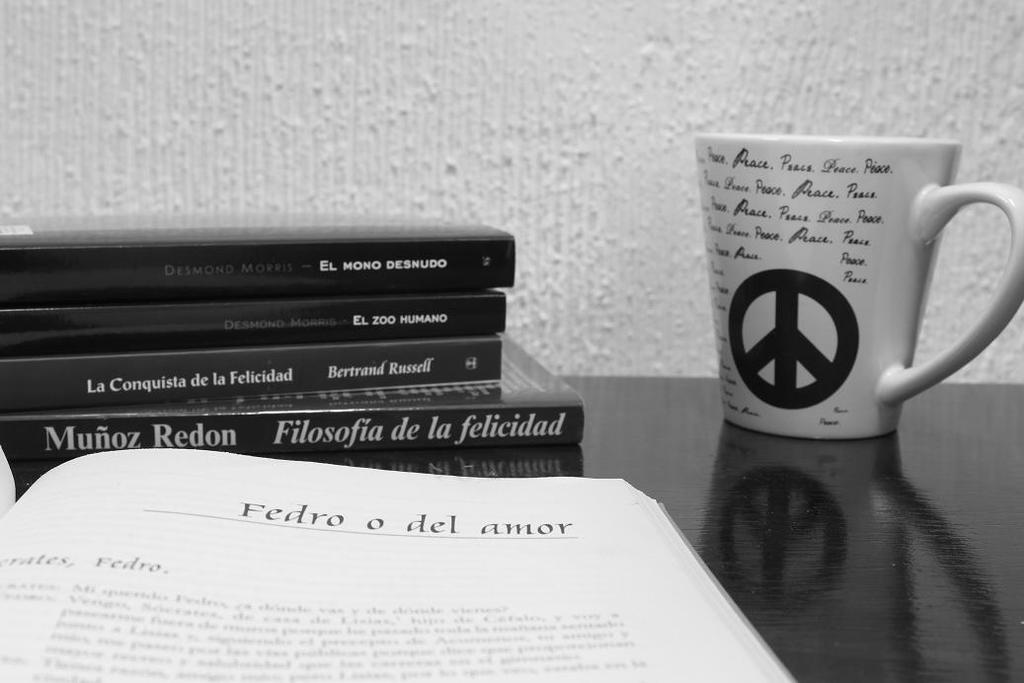<image>
Give a short and clear explanation of the subsequent image. A stack of books with one of them opened, displaying the name Fedro o del amor. 